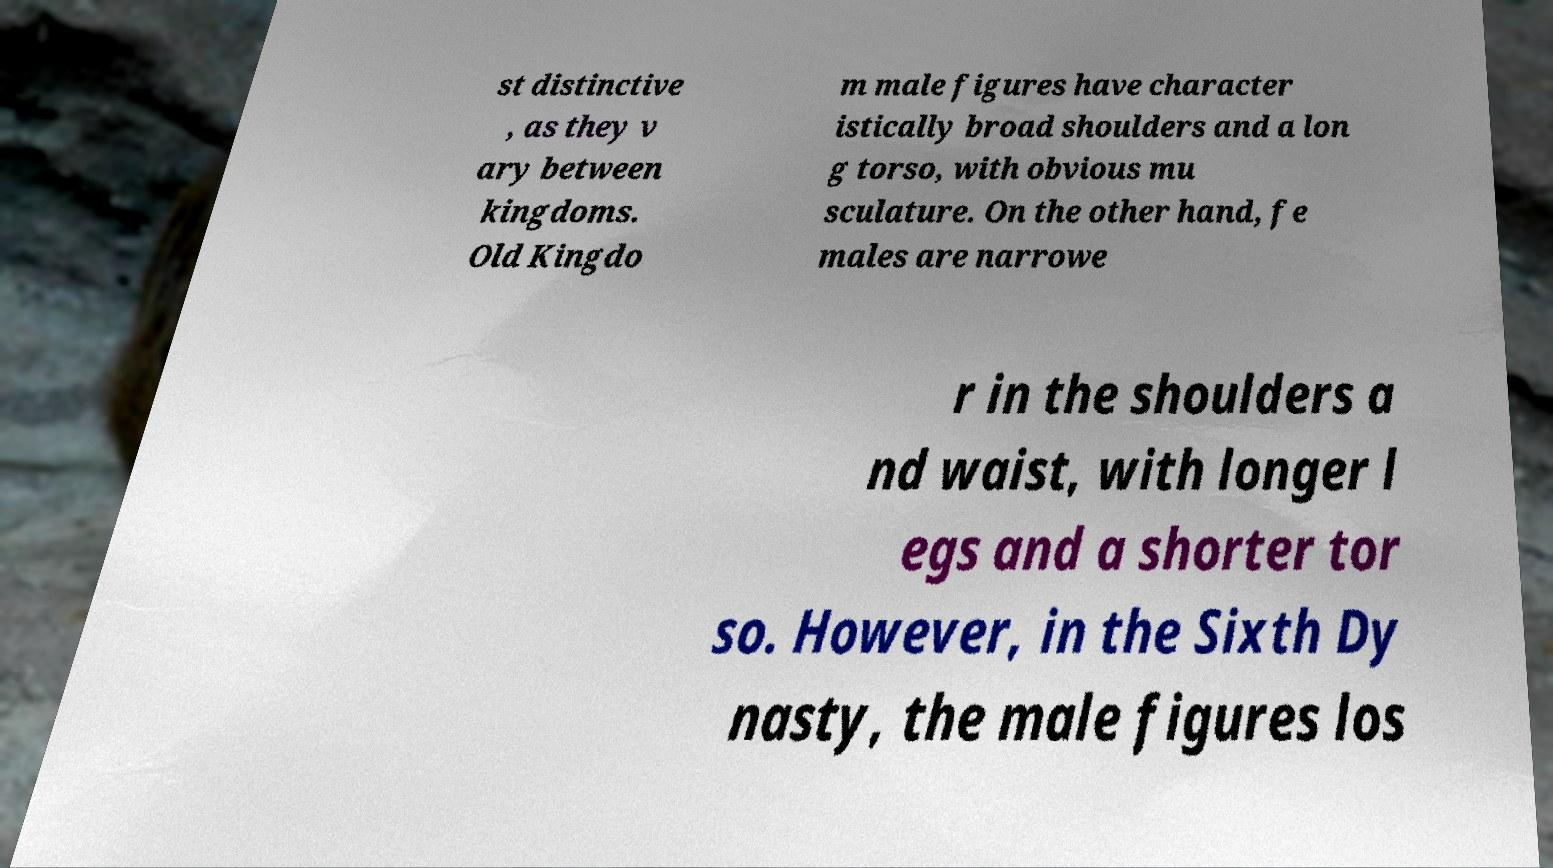Please identify and transcribe the text found in this image. st distinctive , as they v ary between kingdoms. Old Kingdo m male figures have character istically broad shoulders and a lon g torso, with obvious mu sculature. On the other hand, fe males are narrowe r in the shoulders a nd waist, with longer l egs and a shorter tor so. However, in the Sixth Dy nasty, the male figures los 